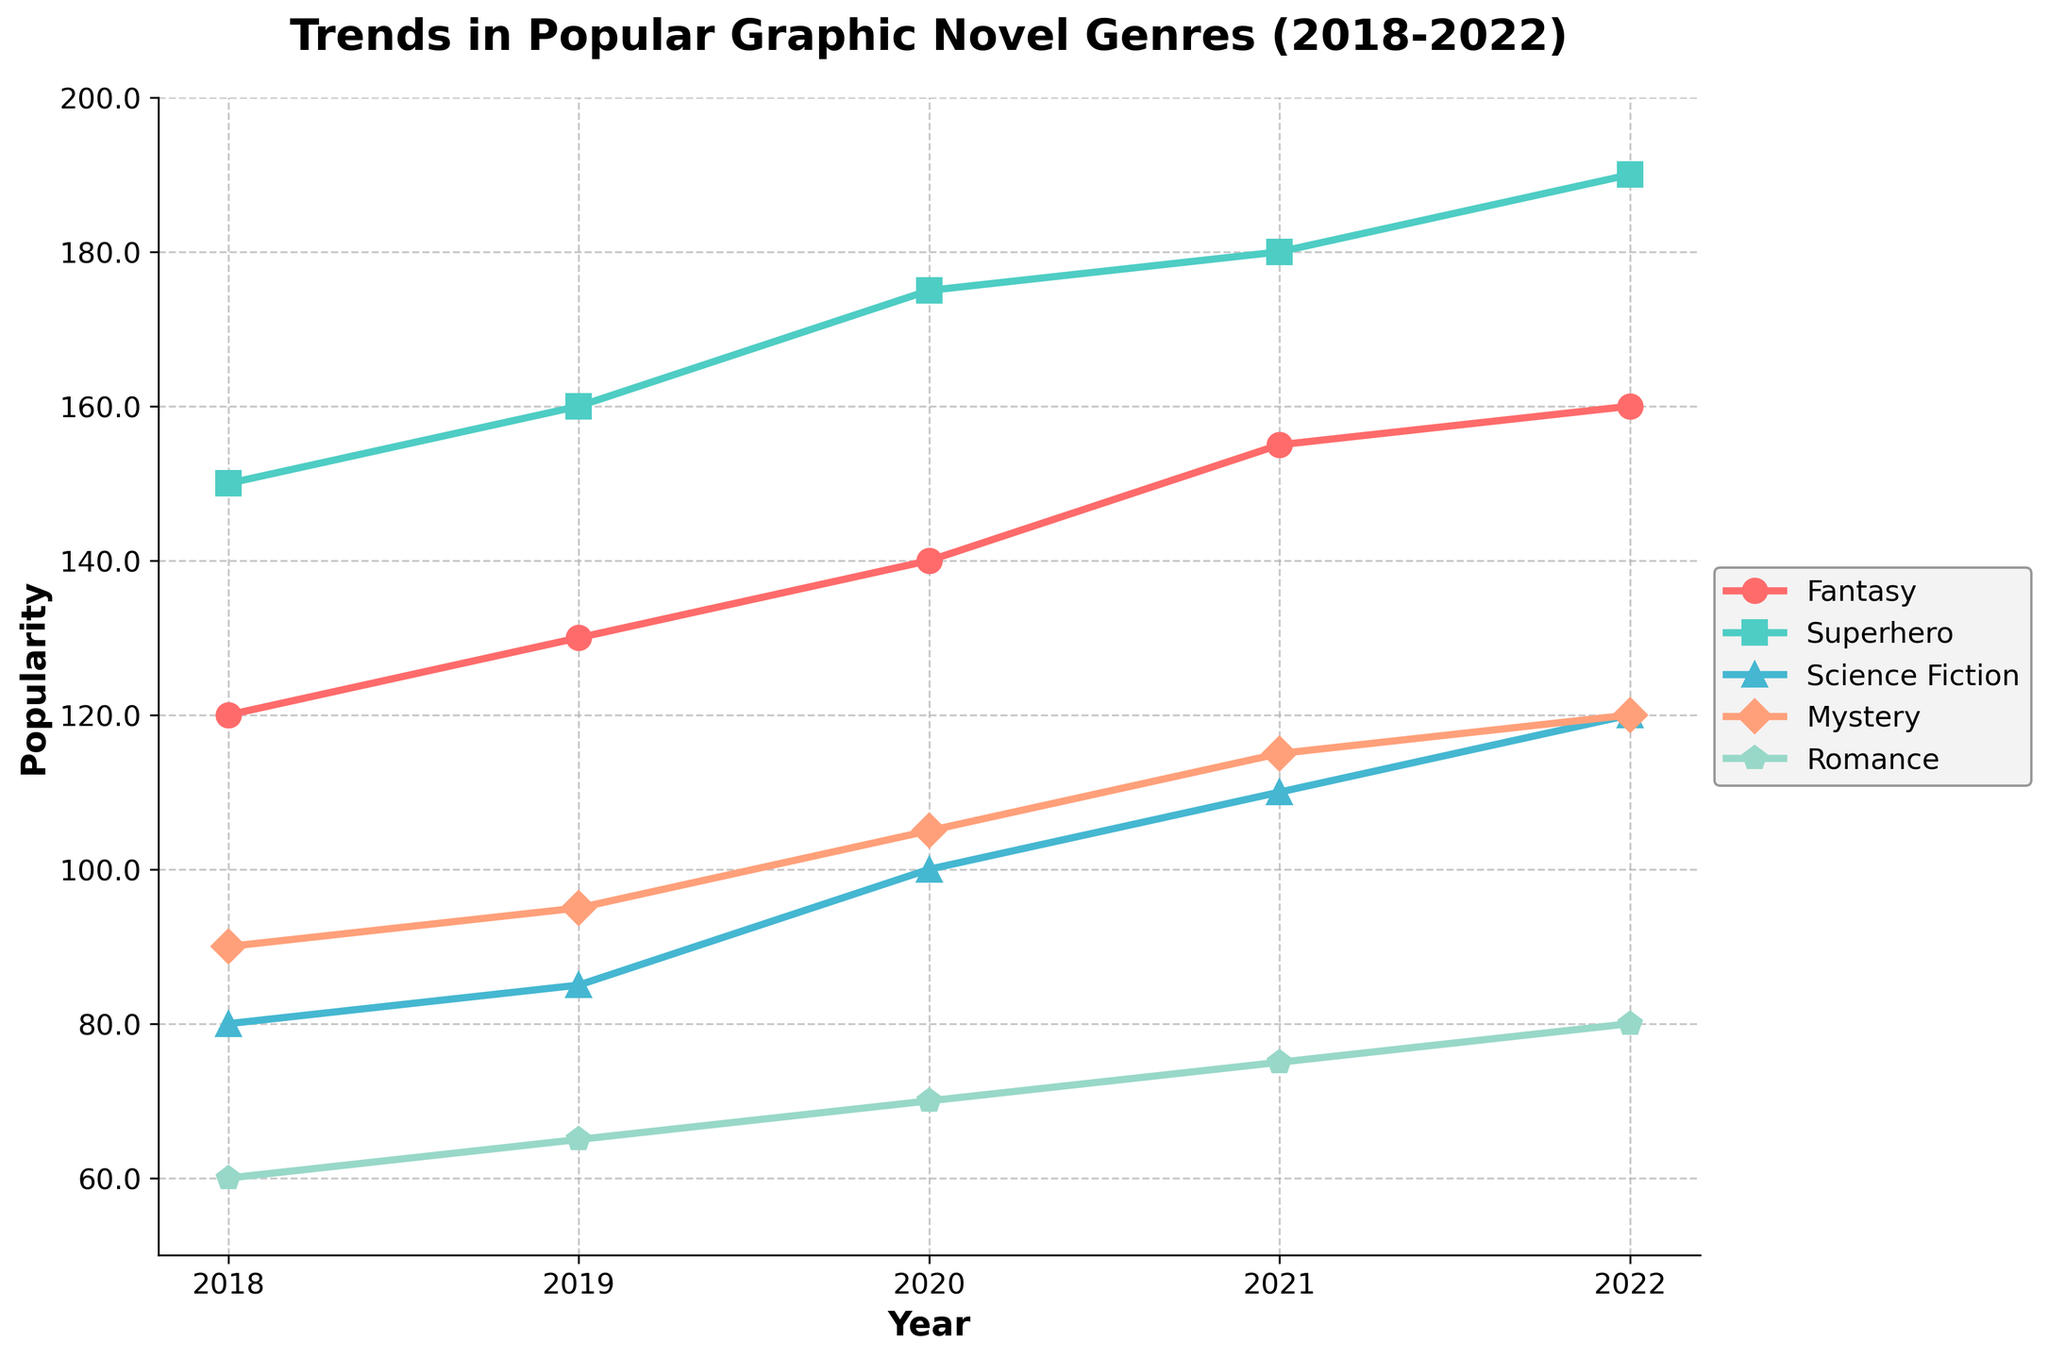What is the title of the plot? The title is located at the top of the plot and is often the most prominent text. For this plot, it reads "Trends in Popular Graphic Novel Genres (2018-2022)".
Answer: Trends in Popular Graphic Novel Genres (2018-2022) Which genre had the highest popularity in 2022? To find this, look at the data points for the year 2022 and identify the highest value among the genres. The "Superhero" genre has a value of 190, which is the highest.
Answer: Superhero What is the general trend of the "Science Fiction" genre over the years? Observe the line for "Science Fiction" across the years. It consistently increases from 80 in 2018 to 120 in 2022, indicating an upward trend.
Answer: Upward trend By how much did the "Mystery" genre's popularity increase from 2020 to 2021? In 2020, the "Mystery" genre had a value of 105, and in 2021, it had 115. Subtract the 2020 value from the 2021 value: 115 - 105 = 10.
Answer: 10 Which genre had the least popularity in 2018 and how can you identify it? Look at the data points for the year 2018 and find the smallest value. The "Romance" genre has the smallest value of 60.
Answer: Romance What is the average popularity of the "Fantasy" genre over the five years? Sum the popularity values of "Fantasy" for each year and divide by the number of years: (120 + 130 + 140 + 155 + 160) / 5 = 141
Answer: 141 How do the popularity trends of "Romance" and "Fantasy" compare? Both genres show an upward trend, but "Fantasy" consistently has higher values compared to "Romance" from 2018 to 2022.
Answer: Both upward, Fantasy higher In which year did "Superhero" genre see the highest increase in popularity compared to the previous year? Calculate the increase for each pair of consecutive years. The largest increase is from 2020 to 2021: 180 - 175 = 5.
Answer: 2021 Does any genre maintain the same popularity for consecutive years? Compare the values year over year for each genre. The "Romance" genre maintains the same popularity of 120 for 2021 and 2022.
Answer: Romance Which genres had a popularity value exceeding 100 in 2022? Look at the data points for the year 2022. "Fantasy" (160), "Superhero" (190), "Science Fiction" (120), and "Mystery" (120) all exceed 100.
Answer: Fantasy, Superhero, Science Fiction, Mystery 